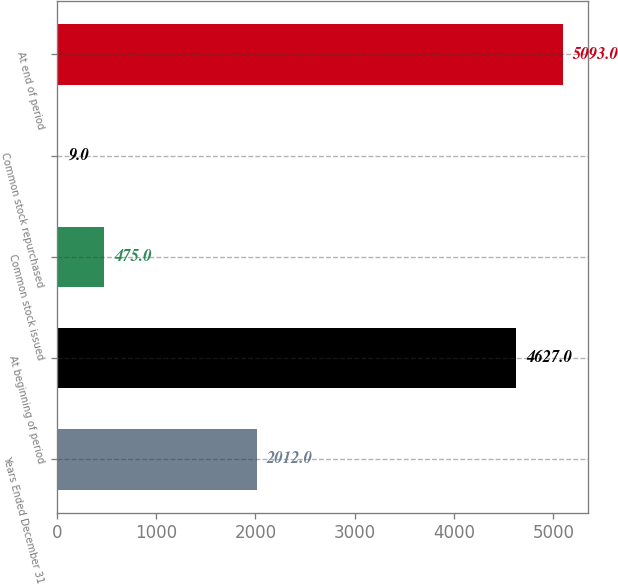Convert chart. <chart><loc_0><loc_0><loc_500><loc_500><bar_chart><fcel>Years Ended December 31<fcel>At beginning of period<fcel>Common stock issued<fcel>Common stock repurchased<fcel>At end of period<nl><fcel>2012<fcel>4627<fcel>475<fcel>9<fcel>5093<nl></chart> 